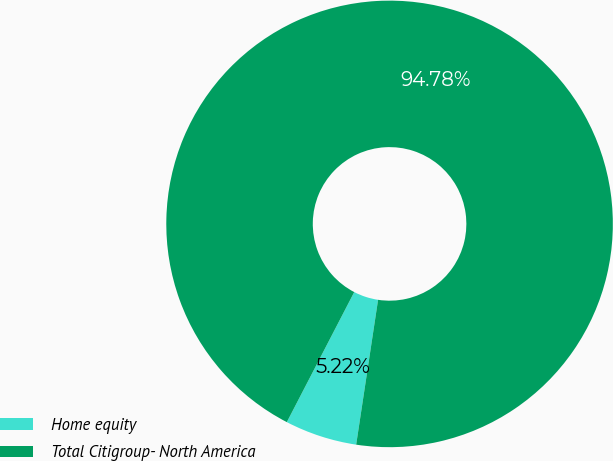<chart> <loc_0><loc_0><loc_500><loc_500><pie_chart><fcel>Home equity<fcel>Total Citigroup- North America<nl><fcel>5.22%<fcel>94.78%<nl></chart> 